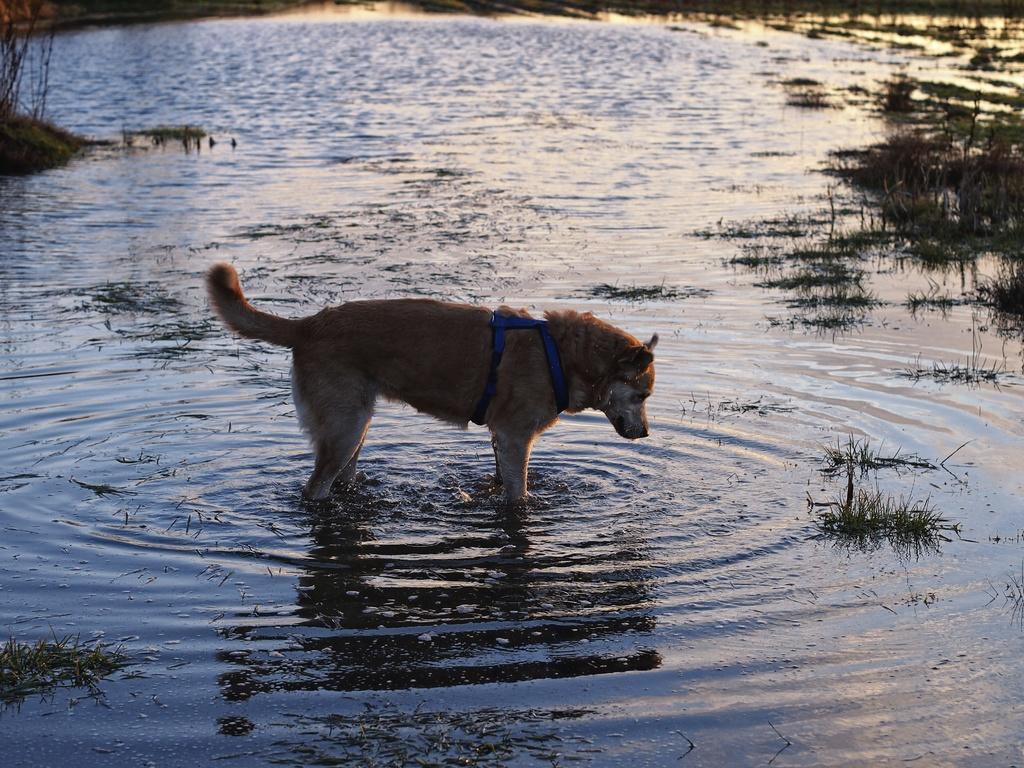Describe this image in one or two sentences. In this picture we can see a dog is standing in the water and in the water there is grass. 